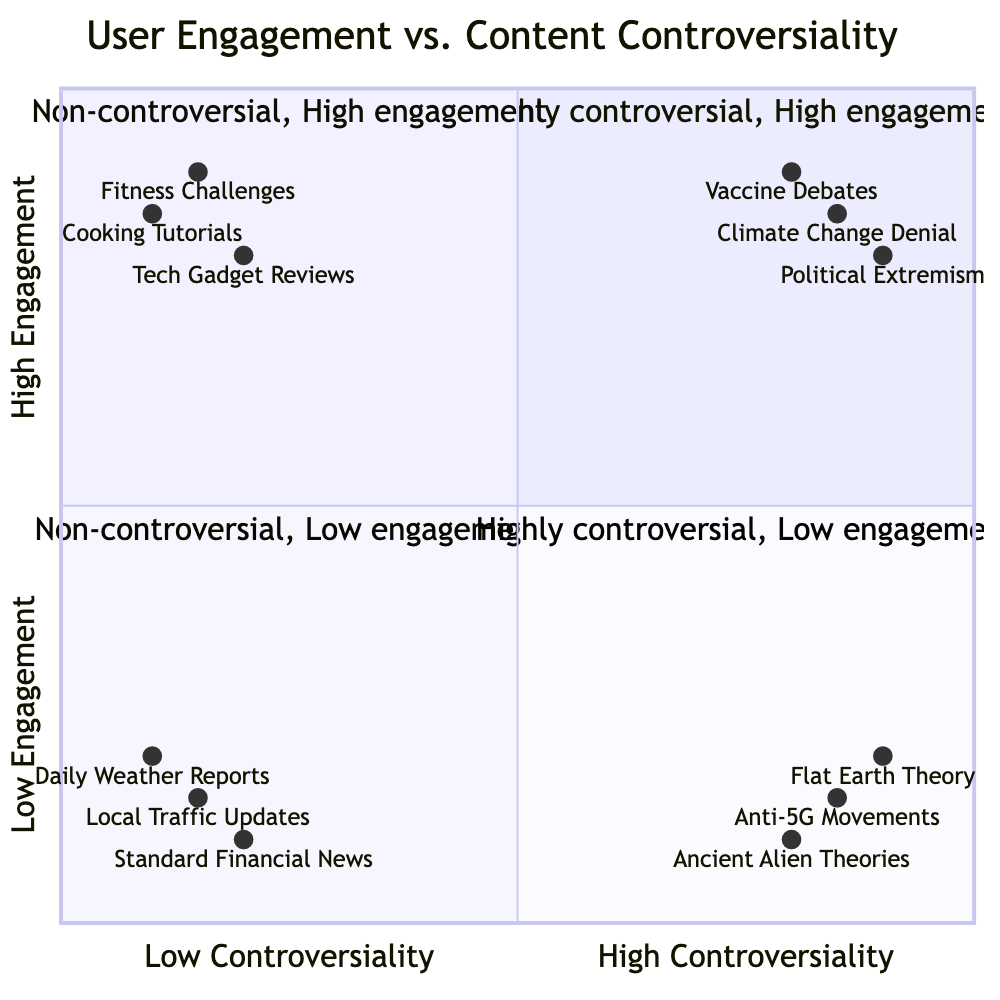What examples are found in the high controversiality, high engagement quadrant? This quadrant contains examples that are both highly controversial and see significant user interaction. According to the provided data, the examples listed are "Vaccine Debates," "Climate Change Denial," and "Political Extremism."
Answer: Vaccine Debates, Climate Change Denial, Political Extremism How many examples are in the low controversiality, low engagement quadrant? This quadrant contains examples that are neither controversial nor engaging. The examples in this quadrant are "Daily Weather Reports," "Local Traffic Updates," and "Standard Financial News." Counting these examples yields a total of three.
Answer: 3 Which content has the highest user engagement and where is it located in the diagram? Among the examples listed, "Fitness Challenges" exhibits the highest user engagement at 0.9. Looking at the coordinates, it lies in the low controversiality, high engagement quadrant.
Answer: 0.9, low controversiality, high engagement What quadrant contains "Anti-5G Movements"? The "Anti-5G Movements" example is classified under high controversiality and low engagement based on the coordinates provided. Thus, it is located in the quadrant representing highly controversial content with minimal user interaction.
Answer: Highly controversial, low engagement In which quadrant would you find content that's non-controversial yet still highly engaging? Content that is categorized as non-controversial while maintaining high user engagement is found in the low controversiality, high engagement quadrant. The examples provided for this quadrant include "Tech Gadget Reviews," "Cooking Tutorials," and "Fitness Challenges."
Answer: Low controversiality, high engagement Which example has the lowest user engagement, and what is its engagement score? The example with the lowest user engagement is "Ancient Alien Theories," which has a score of 0.1 in the low engagement category. This indicates that the content is not only controversial but also not engaging users significantly.
Answer: Ancient Alien Theories, 0.1 How do the controversiality levels of "Vaccine Debates" and "Flat Earth Theory" compare? "Vaccine Debates" has a controversiality score of 0.8, while "Flat Earth Theory" has a score of 0.9. Thus, "Flat Earth Theory" is slightly more controversial than "Vaccine Debates."
Answer: Flat Earth Theory is more controversial Which quadrant shows non-controversial and non-engaging content? The quadrant that represents both non-controversial and non-engaging content is the low controversiality, low engagement quadrant. The examples in this section include "Daily Weather Reports," "Local Traffic Updates," and "Standard Financial News."
Answer: Low controversiality, low engagement 